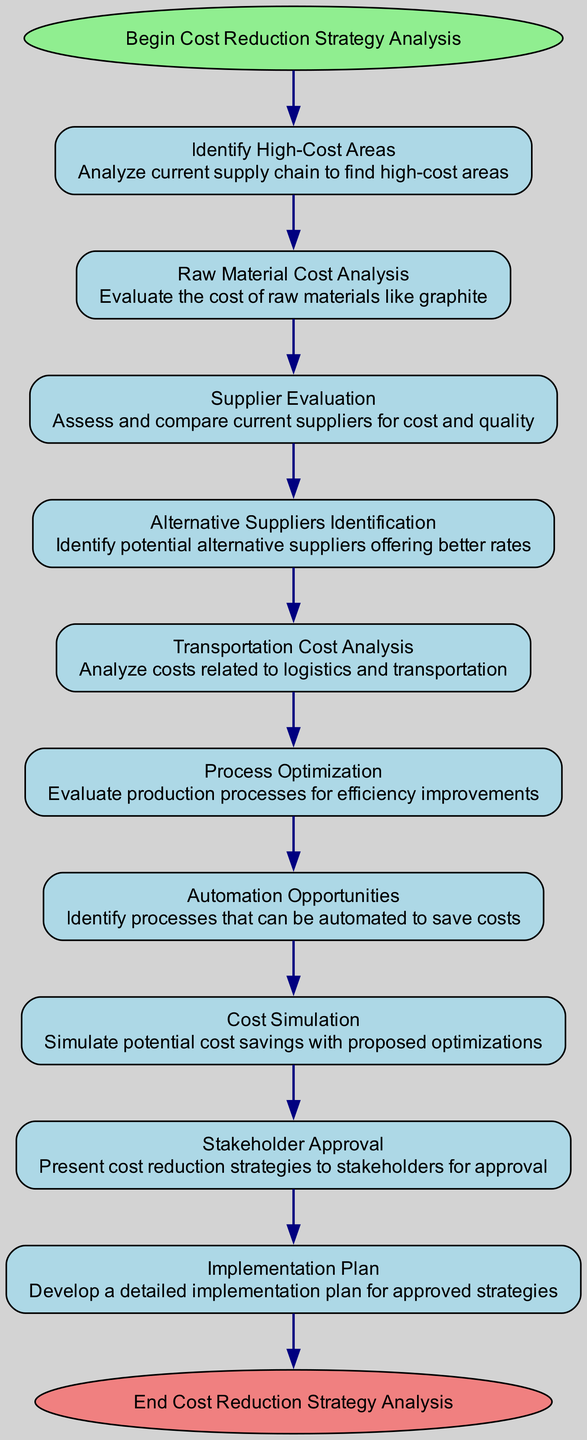What's the first step in the flowchart? The first step, labeled "Identify High-Cost Areas," comes immediately after the "Start" node. It outlines the initial action in the analysis process.
Answer: Identify High-Cost Areas How many steps are included in the cost reduction strategy analysis? By counting the nodes representing the steps in the flowchart, there are a total of 10 distinct steps before reaching the end.
Answer: 10 What is the last step before stakeholder approval? The step before "Stakeholder Approval" is "Cost Simulation," which outlines an essential part of the process where potential savings are modeled.
Answer: Cost Simulation Which step directly connects to the end of the diagram? The step that connects directly to the end node is "Implementation Plan," indicating that a well-defined plan follows the approval of strategies.
Answer: Implementation Plan Which type of analysis is conducted to evaluate transportation costs? The diagram identifies "Transportation Cost Analysis" as the specific evaluation performed to assess logistics expenses.
Answer: Transportation Cost Analysis What is the relationship between process optimization and automation opportunities? "Process Optimization" is evaluated before "Automation Opportunities," indicating that efficiency improvements may lead to identifying automation needs.
Answer: Process Optimization to Automation Opportunities Which step involves identifying alternative suppliers? "Alternative Suppliers Identification" is the step in the flowchart that focuses on finding suppliers that offer better pricing compared to current options.
Answer: Alternative Suppliers Identification Is stakeholder approval a prerequisite for the implementation plan? Yes, the diagram shows that "Stakeholder Approval" must occur before the "Implementation Plan," making it a crucial step in the flowchart.
Answer: Yes What analysis step assesses raw material costs? The analysis of raw material costs is specifically labeled as "Raw Material Cost Analysis" in the flowchart.
Answer: Raw Material Cost Analysis 